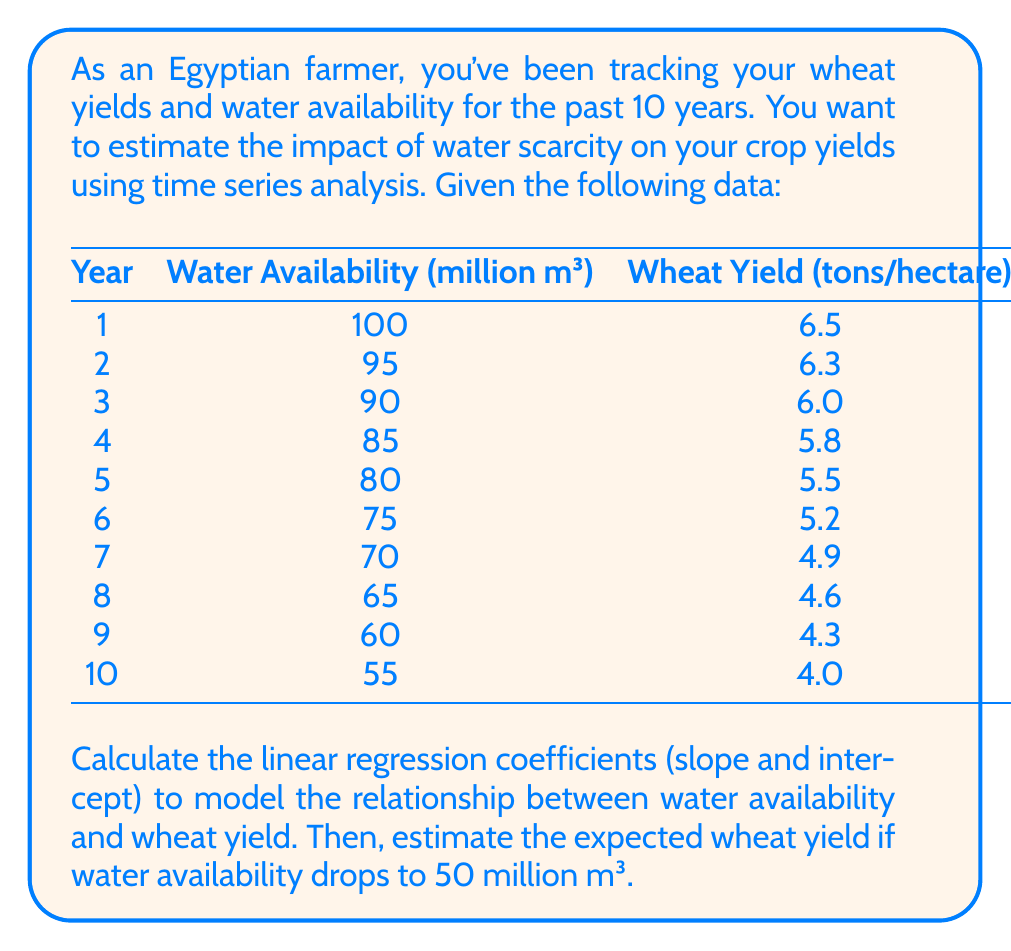Give your solution to this math problem. To solve this problem, we'll use linear regression to model the relationship between water availability (X) and wheat yield (Y). We'll follow these steps:

1. Calculate the means of X and Y:
   $$\bar{X} = \frac{\sum_{i=1}^{10} X_i}{10} = 77.5$$
   $$\bar{Y} = \frac{\sum_{i=1}^{10} Y_i}{10} = 5.31$$

2. Calculate the slope (β) using the formula:
   $$\beta = \frac{\sum_{i=1}^{10} (X_i - \bar{X})(Y_i - \bar{Y})}{\sum_{i=1}^{10} (X_i - \bar{X})^2}$$

   After calculations:
   $$\beta = 0.0556$$

3. Calculate the intercept (α) using the formula:
   $$\alpha = \bar{Y} - \beta\bar{X}$$
   
   $$\alpha = 5.31 - 0.0556 * 77.5 = 1.0009$$

4. The linear regression equation is:
   $$Y = \alpha + \beta X = 1.0009 + 0.0556X$$

5. To estimate the wheat yield when water availability is 50 million m³, we substitute X = 50 into our equation:
   $$Y = 1.0009 + 0.0556 * 50 = 3.7809$$

Therefore, the estimated wheat yield when water availability drops to 50 million m³ is approximately 3.78 tons/hectare.
Answer: 3.78 tons/hectare 